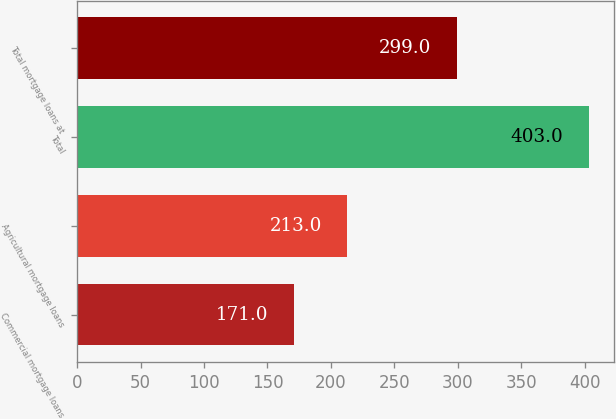Convert chart to OTSL. <chart><loc_0><loc_0><loc_500><loc_500><bar_chart><fcel>Commercial mortgage loans<fcel>Agricultural mortgage loans<fcel>Total<fcel>Total mortgage loans at<nl><fcel>171<fcel>213<fcel>403<fcel>299<nl></chart> 